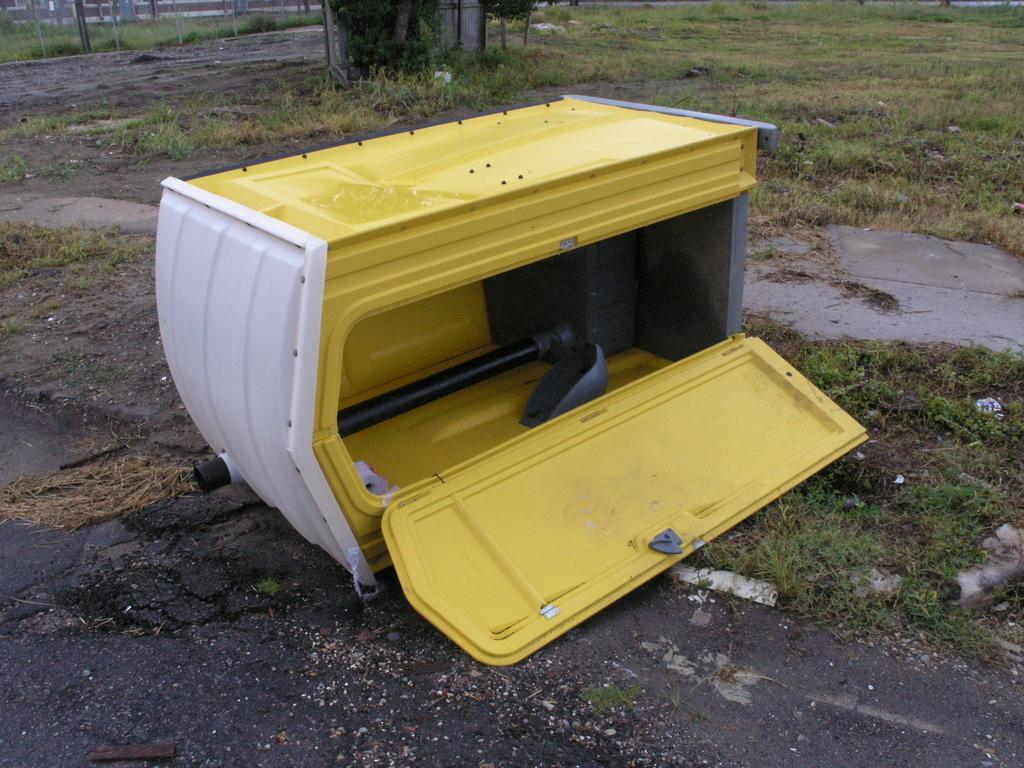What object can be seen in the image? There is a box in the image. What colors are used to paint the box? The box is colored white and yellow. What type of surface is visible on the ground in the image? There is grass on the ground in the image. How many eggs are hidden in the box in the image? There are no eggs present in the image; it only features a box with white and yellow colors on a grassy surface. 